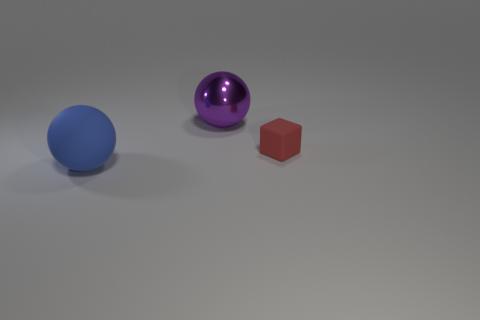Add 1 cyan cylinders. How many objects exist? 4 Subtract all blocks. How many objects are left? 2 Subtract all balls. Subtract all blue rubber cylinders. How many objects are left? 1 Add 2 tiny matte blocks. How many tiny matte blocks are left? 3 Add 3 small things. How many small things exist? 4 Subtract 0 gray blocks. How many objects are left? 3 